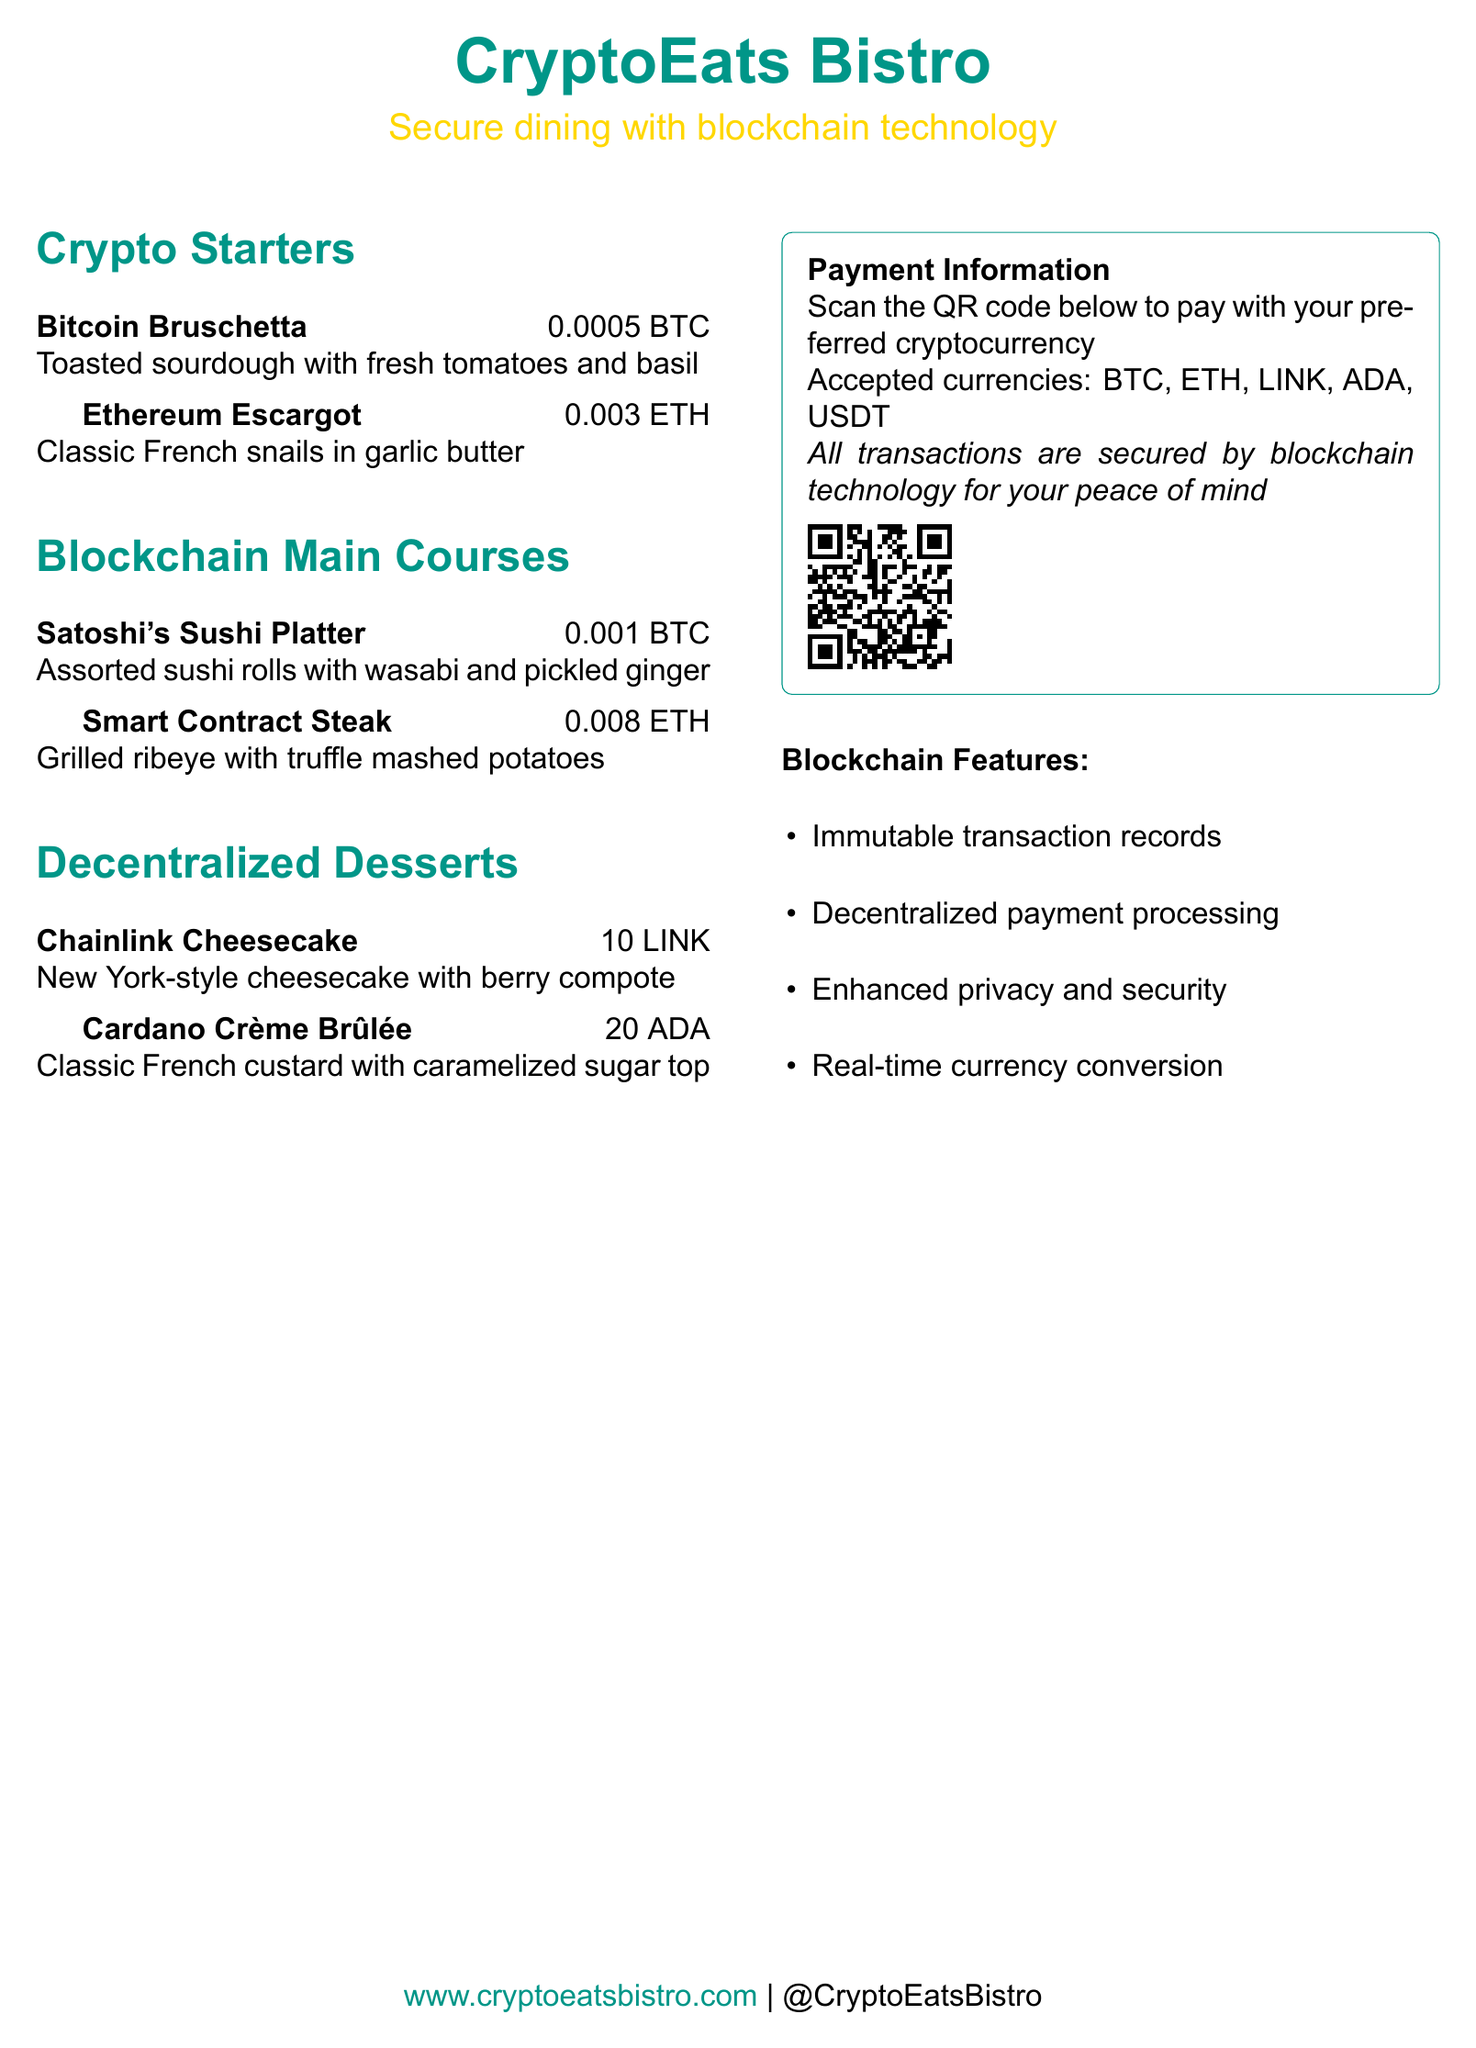What is the name of the restaurant? The name of the restaurant is prominently displayed at the top of the document.
Answer: CryptoEats Bistro What is the price of Bitcoin Bruschetta? The price is listed alongside the menu item in the starters section.
Answer: 0.0005 BTC What dessert is made with 20 ADA? The dessert name can be found in the desserts section, along with its cryptocurrency price.
Answer: Cardano Crème Brûlée How many types of cryptocurrencies are accepted for payment? The document lists the accepted currencies in the payment information section.
Answer: 5 Which dish is associated with Satoshi? The dish name can be found in the main courses section.
Answer: Satoshi's Sushi Platter What technological feature enhances privacy in transactions? The feature is mentioned in the list detailing blockchain features.
Answer: Enhanced privacy and security What is the main ingredient in Ethereum Escargot? The dish description provides details about the main ingredient.
Answer: Snails What type of technology secures the transactions? The document states the technology used in the payment processing section.
Answer: Blockchain technology What is the website for the restaurant? The website is displayed at the bottom of the document.
Answer: www.cryptoeatsbistro.com 